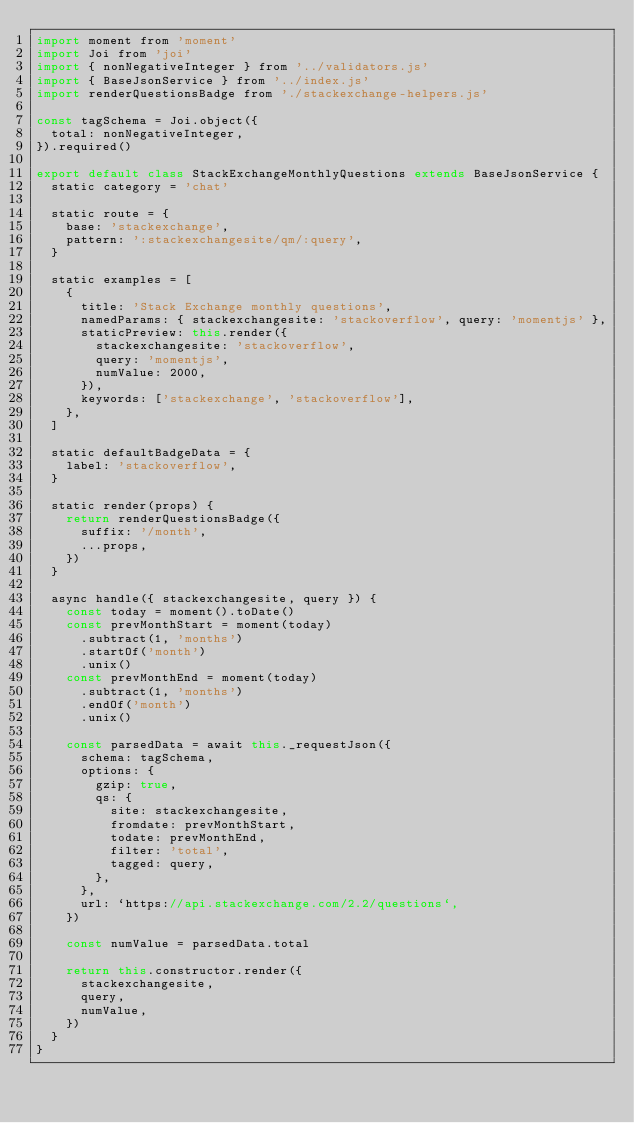Convert code to text. <code><loc_0><loc_0><loc_500><loc_500><_JavaScript_>import moment from 'moment'
import Joi from 'joi'
import { nonNegativeInteger } from '../validators.js'
import { BaseJsonService } from '../index.js'
import renderQuestionsBadge from './stackexchange-helpers.js'

const tagSchema = Joi.object({
  total: nonNegativeInteger,
}).required()

export default class StackExchangeMonthlyQuestions extends BaseJsonService {
  static category = 'chat'

  static route = {
    base: 'stackexchange',
    pattern: ':stackexchangesite/qm/:query',
  }

  static examples = [
    {
      title: 'Stack Exchange monthly questions',
      namedParams: { stackexchangesite: 'stackoverflow', query: 'momentjs' },
      staticPreview: this.render({
        stackexchangesite: 'stackoverflow',
        query: 'momentjs',
        numValue: 2000,
      }),
      keywords: ['stackexchange', 'stackoverflow'],
    },
  ]

  static defaultBadgeData = {
    label: 'stackoverflow',
  }

  static render(props) {
    return renderQuestionsBadge({
      suffix: '/month',
      ...props,
    })
  }

  async handle({ stackexchangesite, query }) {
    const today = moment().toDate()
    const prevMonthStart = moment(today)
      .subtract(1, 'months')
      .startOf('month')
      .unix()
    const prevMonthEnd = moment(today)
      .subtract(1, 'months')
      .endOf('month')
      .unix()

    const parsedData = await this._requestJson({
      schema: tagSchema,
      options: {
        gzip: true,
        qs: {
          site: stackexchangesite,
          fromdate: prevMonthStart,
          todate: prevMonthEnd,
          filter: 'total',
          tagged: query,
        },
      },
      url: `https://api.stackexchange.com/2.2/questions`,
    })

    const numValue = parsedData.total

    return this.constructor.render({
      stackexchangesite,
      query,
      numValue,
    })
  }
}
</code> 